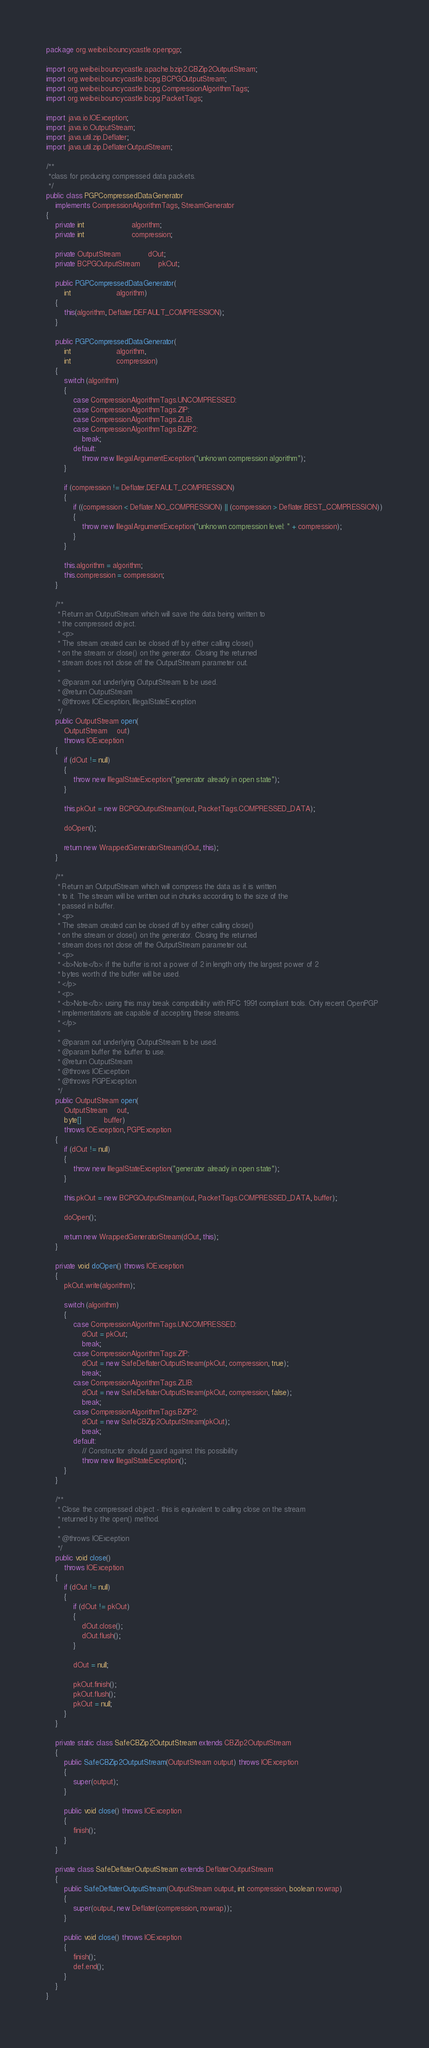Convert code to text. <code><loc_0><loc_0><loc_500><loc_500><_Java_>package org.weibei.bouncycastle.openpgp;

import org.weibei.bouncycastle.apache.bzip2.CBZip2OutputStream;
import org.weibei.bouncycastle.bcpg.BCPGOutputStream;
import org.weibei.bouncycastle.bcpg.CompressionAlgorithmTags;
import org.weibei.bouncycastle.bcpg.PacketTags;

import java.io.IOException;
import java.io.OutputStream;
import java.util.zip.Deflater;
import java.util.zip.DeflaterOutputStream;

/**
 *class for producing compressed data packets.
 */
public class PGPCompressedDataGenerator 
    implements CompressionAlgorithmTags, StreamGenerator
{
    private int                     algorithm;
    private int                     compression;

    private OutputStream            dOut;
    private BCPGOutputStream        pkOut;
    
    public PGPCompressedDataGenerator(
        int                    algorithm)
    {
        this(algorithm, Deflater.DEFAULT_COMPRESSION);
    }
                    
    public PGPCompressedDataGenerator(
        int                    algorithm,
        int                    compression)
    {
        switch (algorithm)
        {
            case CompressionAlgorithmTags.UNCOMPRESSED:
            case CompressionAlgorithmTags.ZIP:
            case CompressionAlgorithmTags.ZLIB:
            case CompressionAlgorithmTags.BZIP2:
                break;
            default:
                throw new IllegalArgumentException("unknown compression algorithm");
        }

        if (compression != Deflater.DEFAULT_COMPRESSION)
        {
            if ((compression < Deflater.NO_COMPRESSION) || (compression > Deflater.BEST_COMPRESSION))
            {
                throw new IllegalArgumentException("unknown compression level: " + compression);
            }
        }

        this.algorithm = algorithm;
        this.compression = compression;
    }

    /**
     * Return an OutputStream which will save the data being written to 
     * the compressed object.
     * <p>
     * The stream created can be closed off by either calling close()
     * on the stream or close() on the generator. Closing the returned
     * stream does not close off the OutputStream parameter out.
     * 
     * @param out underlying OutputStream to be used.
     * @return OutputStream
     * @throws IOException, IllegalStateException
     */        
    public OutputStream open(
        OutputStream    out)
        throws IOException
    {
        if (dOut != null)
        {
            throw new IllegalStateException("generator already in open state");
        }

        this.pkOut = new BCPGOutputStream(out, PacketTags.COMPRESSED_DATA);

        doOpen();

        return new WrappedGeneratorStream(dOut, this);
    }
    
    /**
     * Return an OutputStream which will compress the data as it is written
     * to it. The stream will be written out in chunks according to the size of the
     * passed in buffer.
     * <p>
     * The stream created can be closed off by either calling close()
     * on the stream or close() on the generator. Closing the returned
     * stream does not close off the OutputStream parameter out.
     * <p>
     * <b>Note</b>: if the buffer is not a power of 2 in length only the largest power of 2
     * bytes worth of the buffer will be used.
     * </p>
     * <p>
     * <b>Note</b>: using this may break compatibility with RFC 1991 compliant tools. Only recent OpenPGP
     * implementations are capable of accepting these streams.
     * </p>
     * 
     * @param out underlying OutputStream to be used.
     * @param buffer the buffer to use.
     * @return OutputStream
     * @throws IOException
     * @throws PGPException
     */
    public OutputStream open(
        OutputStream    out,
        byte[]          buffer)
        throws IOException, PGPException
    {
        if (dOut != null)
        {
            throw new IllegalStateException("generator already in open state");
        }

        this.pkOut = new BCPGOutputStream(out, PacketTags.COMPRESSED_DATA, buffer);

        doOpen();

        return new WrappedGeneratorStream(dOut, this);
    }

    private void doOpen() throws IOException
    {
        pkOut.write(algorithm);

        switch (algorithm)
        {
            case CompressionAlgorithmTags.UNCOMPRESSED:
                dOut = pkOut;
                break;
            case CompressionAlgorithmTags.ZIP:
                dOut = new SafeDeflaterOutputStream(pkOut, compression, true);
                break;
            case CompressionAlgorithmTags.ZLIB:
                dOut = new SafeDeflaterOutputStream(pkOut, compression, false);
                break;
            case CompressionAlgorithmTags.BZIP2:
                dOut = new SafeCBZip2OutputStream(pkOut);
                break;
            default:
                // Constructor should guard against this possibility
                throw new IllegalStateException();
        }
    }

    /**
     * Close the compressed object - this is equivalent to calling close on the stream
     * returned by the open() method.
     * 
     * @throws IOException
     */
    public void close()
        throws IOException
    {
        if (dOut != null)
        {
            if (dOut != pkOut)
            {
                dOut.close();
                dOut.flush();
            }

            dOut = null;

            pkOut.finish();
            pkOut.flush();
            pkOut = null;
        }
    }

    private static class SafeCBZip2OutputStream extends CBZip2OutputStream
    {
        public SafeCBZip2OutputStream(OutputStream output) throws IOException
        {
            super(output);
        }

        public void close() throws IOException
        {
            finish();
        }
    }

    private class SafeDeflaterOutputStream extends DeflaterOutputStream
    {
        public SafeDeflaterOutputStream(OutputStream output, int compression, boolean nowrap)
        {
            super(output, new Deflater(compression, nowrap));
        }

        public void close() throws IOException
        {
            finish();
            def.end();
        }
    }
}
</code> 